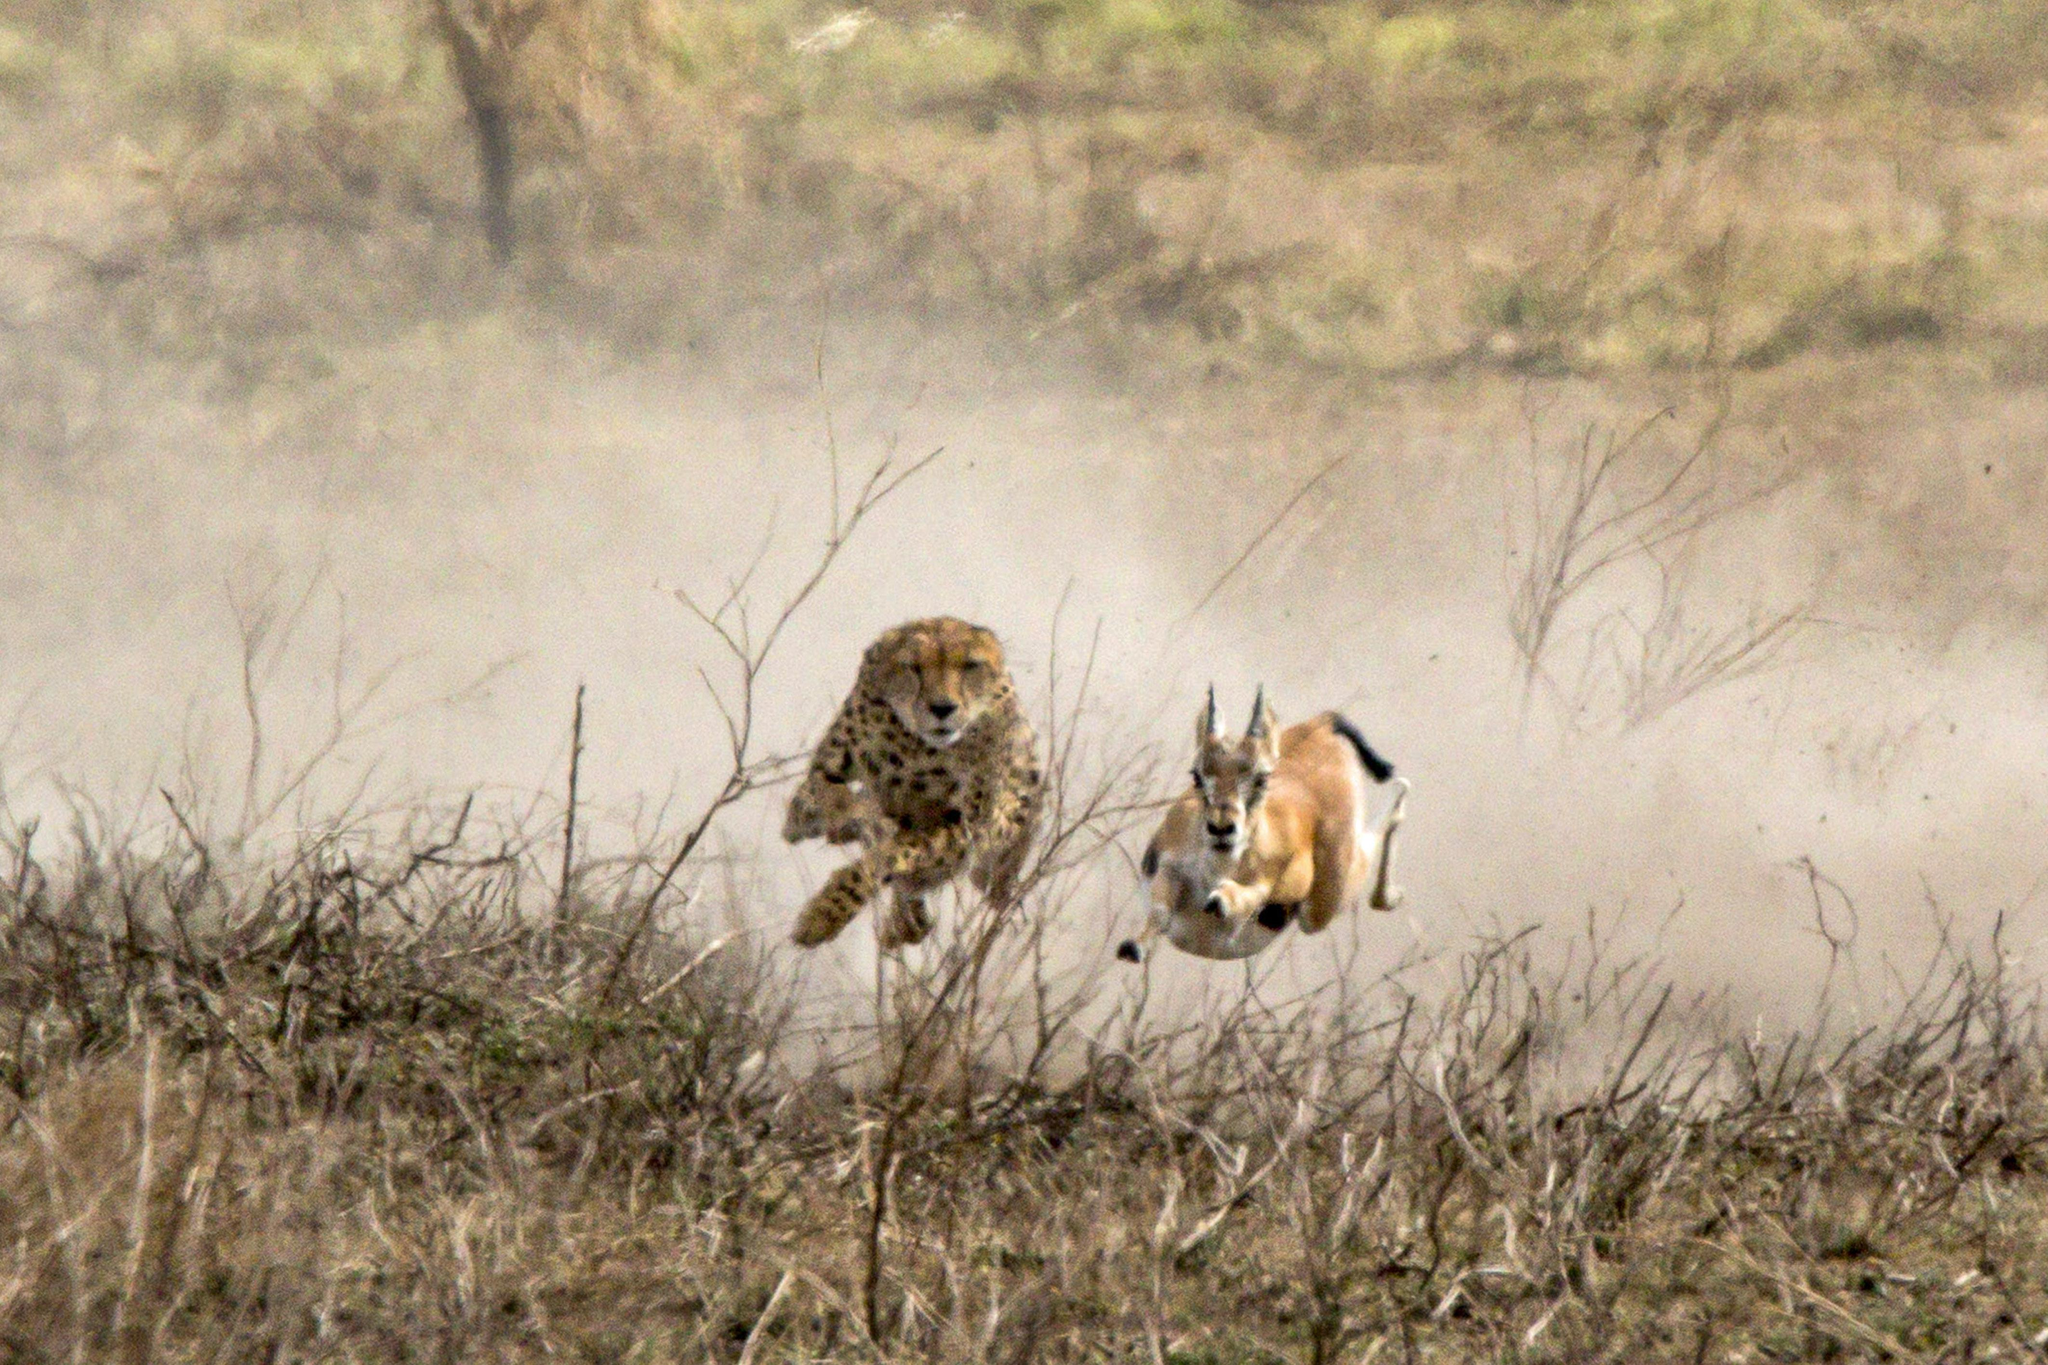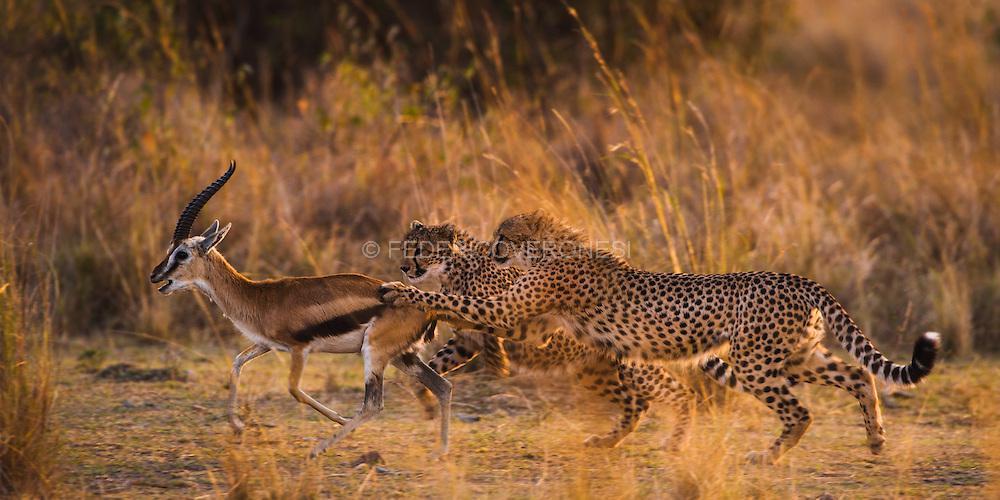The first image is the image on the left, the second image is the image on the right. Assess this claim about the two images: "Multiple cheetahs are bounding leftward to attack a gazelle in one image.". Correct or not? Answer yes or no. Yes. 